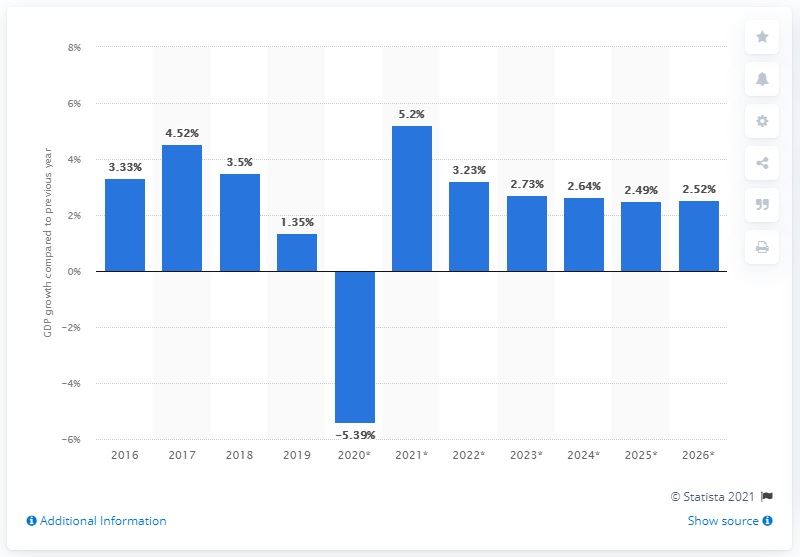Mention a couple of crucial points in this snapshot. According to forecasts, Singapore's GDP is expected to decline by 1.35% in 2019. 